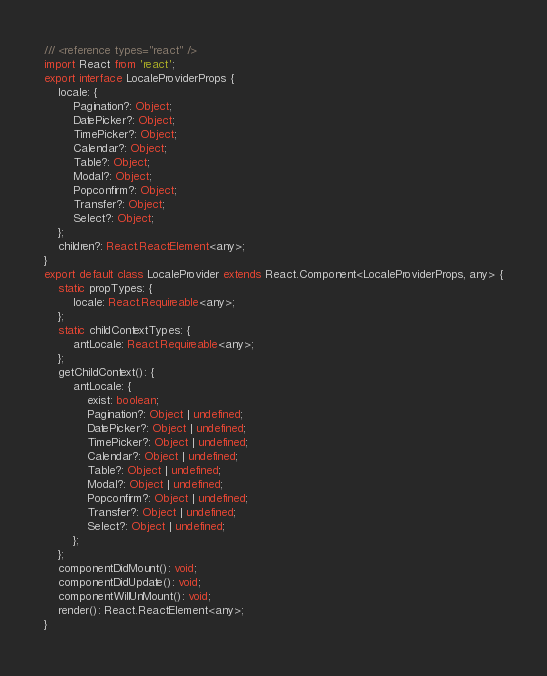<code> <loc_0><loc_0><loc_500><loc_500><_TypeScript_>/// <reference types="react" />
import React from 'react';
export interface LocaleProviderProps {
    locale: {
        Pagination?: Object;
        DatePicker?: Object;
        TimePicker?: Object;
        Calendar?: Object;
        Table?: Object;
        Modal?: Object;
        Popconfirm?: Object;
        Transfer?: Object;
        Select?: Object;
    };
    children?: React.ReactElement<any>;
}
export default class LocaleProvider extends React.Component<LocaleProviderProps, any> {
    static propTypes: {
        locale: React.Requireable<any>;
    };
    static childContextTypes: {
        antLocale: React.Requireable<any>;
    };
    getChildContext(): {
        antLocale: {
            exist: boolean;
            Pagination?: Object | undefined;
            DatePicker?: Object | undefined;
            TimePicker?: Object | undefined;
            Calendar?: Object | undefined;
            Table?: Object | undefined;
            Modal?: Object | undefined;
            Popconfirm?: Object | undefined;
            Transfer?: Object | undefined;
            Select?: Object | undefined;
        };
    };
    componentDidMount(): void;
    componentDidUpdate(): void;
    componentWillUnMount(): void;
    render(): React.ReactElement<any>;
}
</code> 